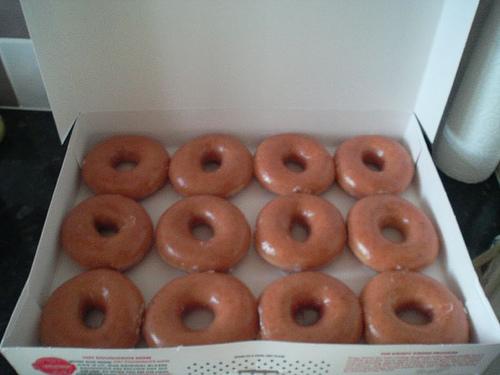What color is the donut box?
Give a very brief answer. White. What is next to the doughnuts?
Give a very brief answer. Paper towels. What is the predominant color of these donuts?
Keep it brief. Brown. Is this a baker's dozen?
Answer briefly. No. How many chocolate doughnuts are there?
Quick response, please. 0. What type of donuts are these?
Short answer required. Glazed. Are the donuts on plates?
Answer briefly. No. 